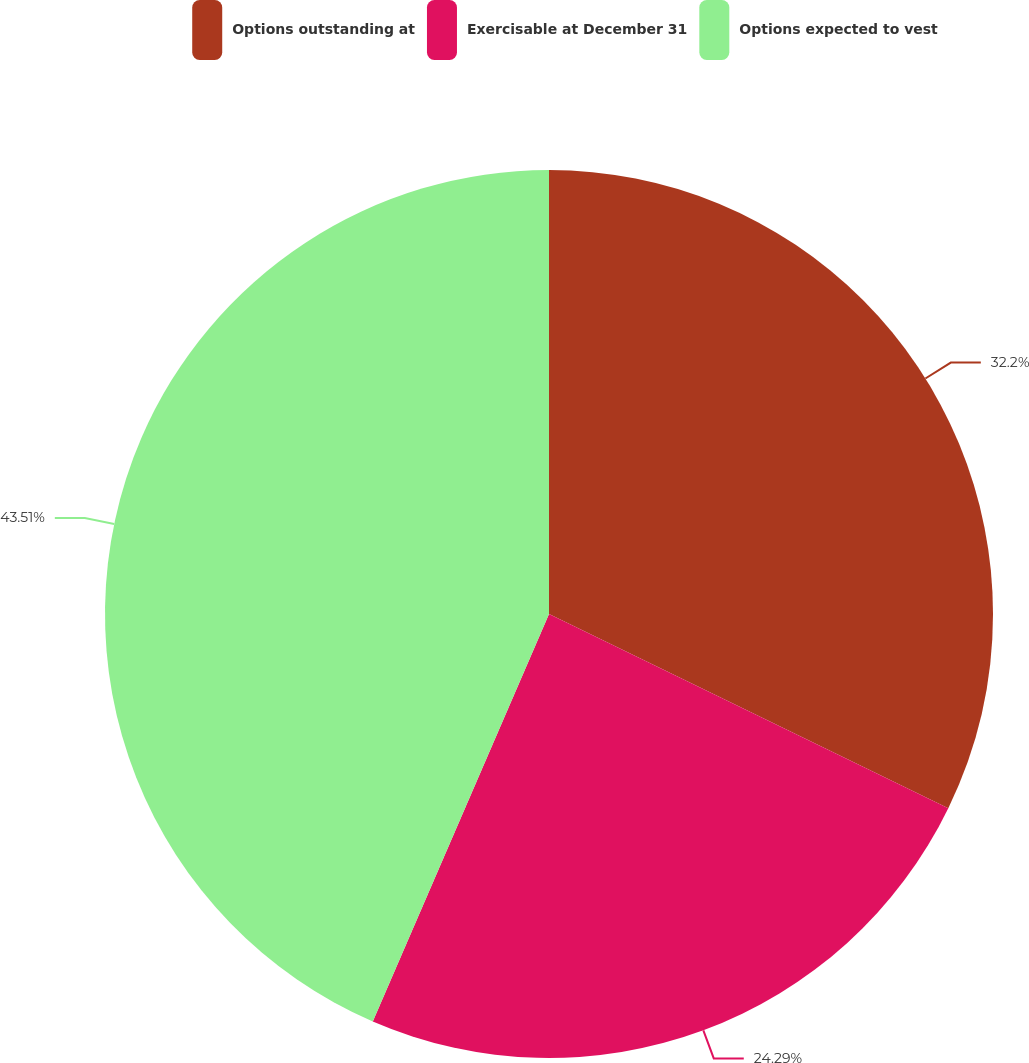<chart> <loc_0><loc_0><loc_500><loc_500><pie_chart><fcel>Options outstanding at<fcel>Exercisable at December 31<fcel>Options expected to vest<nl><fcel>32.2%<fcel>24.29%<fcel>43.5%<nl></chart> 